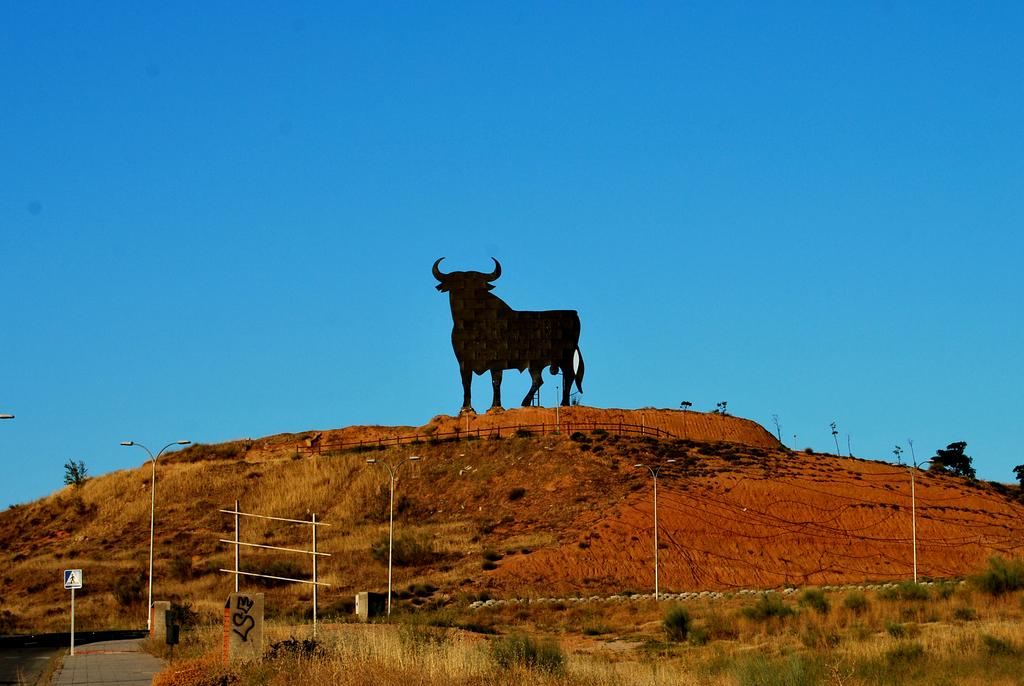What is the main subject of the image? There is a statue of a bull in the image. How is the statue positioned in the image? The statue is standing on the ground. What else can be seen on the ground in the image? There are plants on the ground in the image. What type of pear is hanging from the statue in the image? There is no pear present in the image; it features a statue of a bull standing on the ground with plants nearby. 